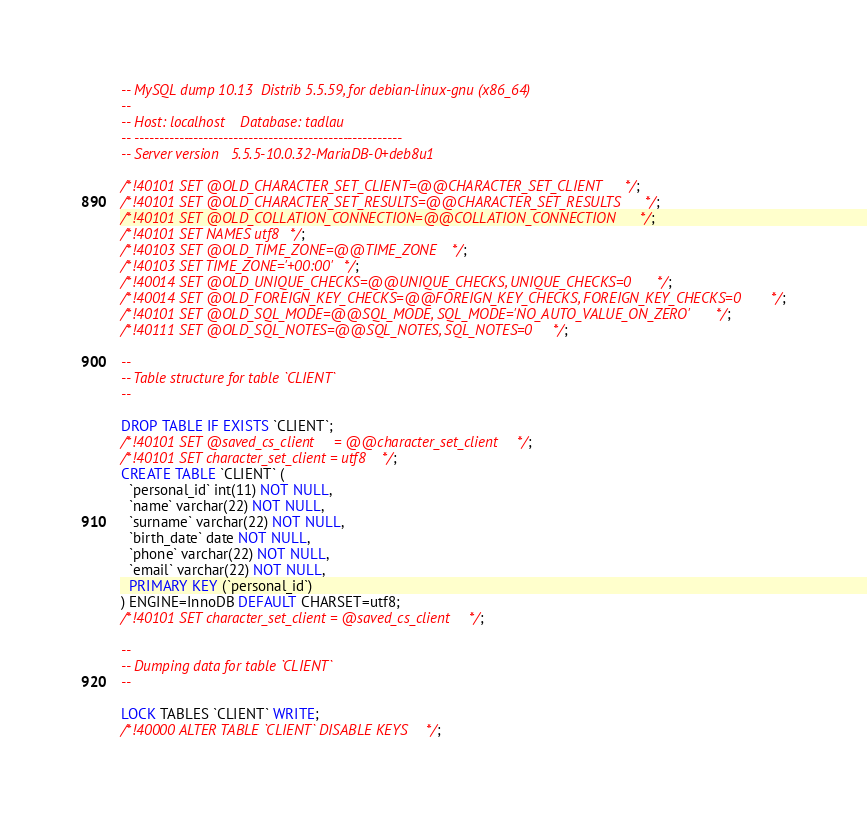Convert code to text. <code><loc_0><loc_0><loc_500><loc_500><_SQL_>-- MySQL dump 10.13  Distrib 5.5.59, for debian-linux-gnu (x86_64)
--
-- Host: localhost    Database: tadlau
-- ------------------------------------------------------
-- Server version	5.5.5-10.0.32-MariaDB-0+deb8u1

/*!40101 SET @OLD_CHARACTER_SET_CLIENT=@@CHARACTER_SET_CLIENT */;
/*!40101 SET @OLD_CHARACTER_SET_RESULTS=@@CHARACTER_SET_RESULTS */;
/*!40101 SET @OLD_COLLATION_CONNECTION=@@COLLATION_CONNECTION */;
/*!40101 SET NAMES utf8 */;
/*!40103 SET @OLD_TIME_ZONE=@@TIME_ZONE */;
/*!40103 SET TIME_ZONE='+00:00' */;
/*!40014 SET @OLD_UNIQUE_CHECKS=@@UNIQUE_CHECKS, UNIQUE_CHECKS=0 */;
/*!40014 SET @OLD_FOREIGN_KEY_CHECKS=@@FOREIGN_KEY_CHECKS, FOREIGN_KEY_CHECKS=0 */;
/*!40101 SET @OLD_SQL_MODE=@@SQL_MODE, SQL_MODE='NO_AUTO_VALUE_ON_ZERO' */;
/*!40111 SET @OLD_SQL_NOTES=@@SQL_NOTES, SQL_NOTES=0 */;

--
-- Table structure for table `CLIENT`
--

DROP TABLE IF EXISTS `CLIENT`;
/*!40101 SET @saved_cs_client     = @@character_set_client */;
/*!40101 SET character_set_client = utf8 */;
CREATE TABLE `CLIENT` (
  `personal_id` int(11) NOT NULL,
  `name` varchar(22) NOT NULL,
  `surname` varchar(22) NOT NULL,
  `birth_date` date NOT NULL,
  `phone` varchar(22) NOT NULL,
  `email` varchar(22) NOT NULL,
  PRIMARY KEY (`personal_id`)
) ENGINE=InnoDB DEFAULT CHARSET=utf8;
/*!40101 SET character_set_client = @saved_cs_client */;

--
-- Dumping data for table `CLIENT`
--

LOCK TABLES `CLIENT` WRITE;
/*!40000 ALTER TABLE `CLIENT` DISABLE KEYS */;</code> 